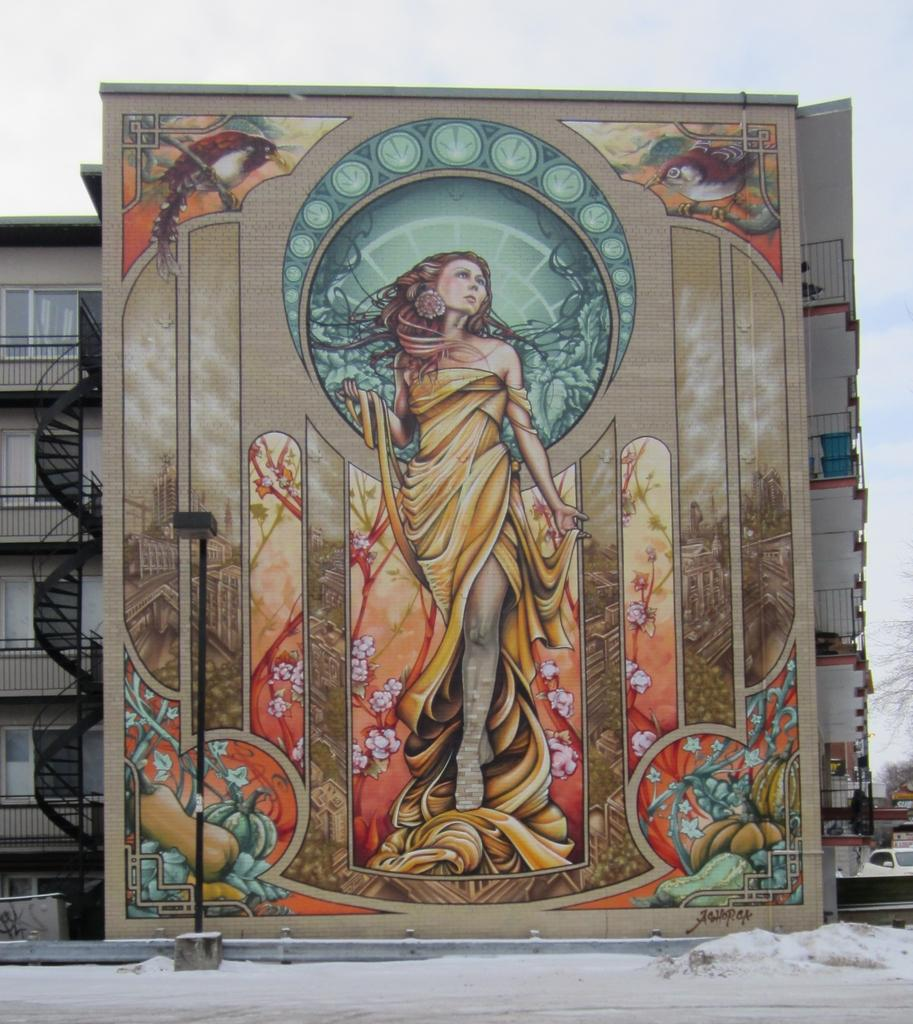What is the main subject of the image? There is a painting in the image. What is located in front of the painting? There is a pole in front of the painting. What type of weather is depicted in the image? There is snow in the image. What can be seen in the background of the image? Metal rods and buildings are visible in the background of the image. What type of vehicles are present in the image? Vehicles are present in the image. Can you describe the spark of the truck in the image? There is no truck present in the image, so there is no spark to describe. 